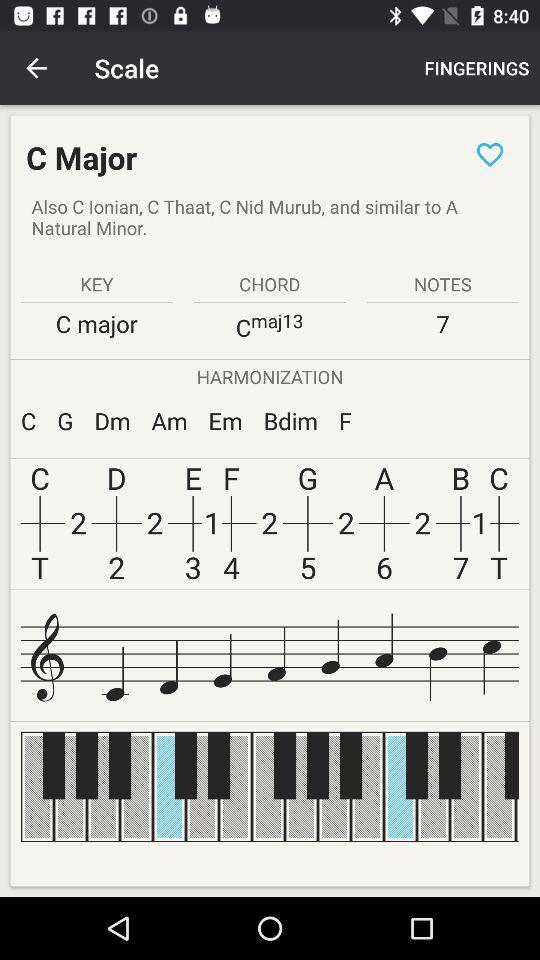Which harmonization sequence is mentioned? The mentioned harmonization sequence is "C G Dm Am Em Bdim F". 